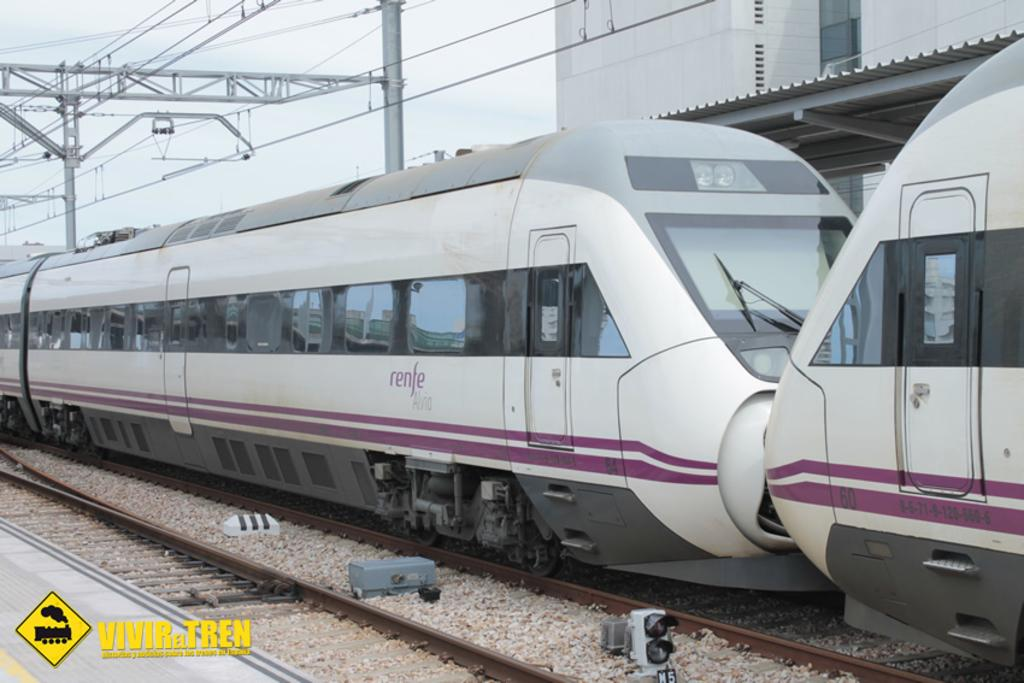<image>
Give a short and clear explanation of the subsequent image. Two trains nose to nose, the word Renfe is visible. 